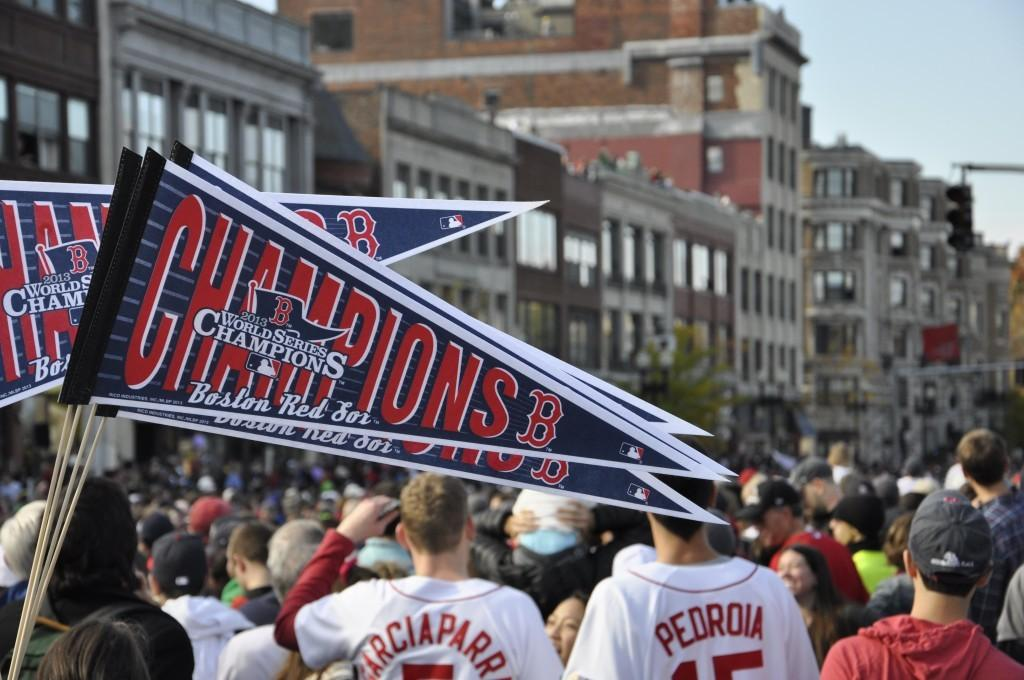<image>
Provide a brief description of the given image. Pennants that say Champions 2013 World Series Champions. 